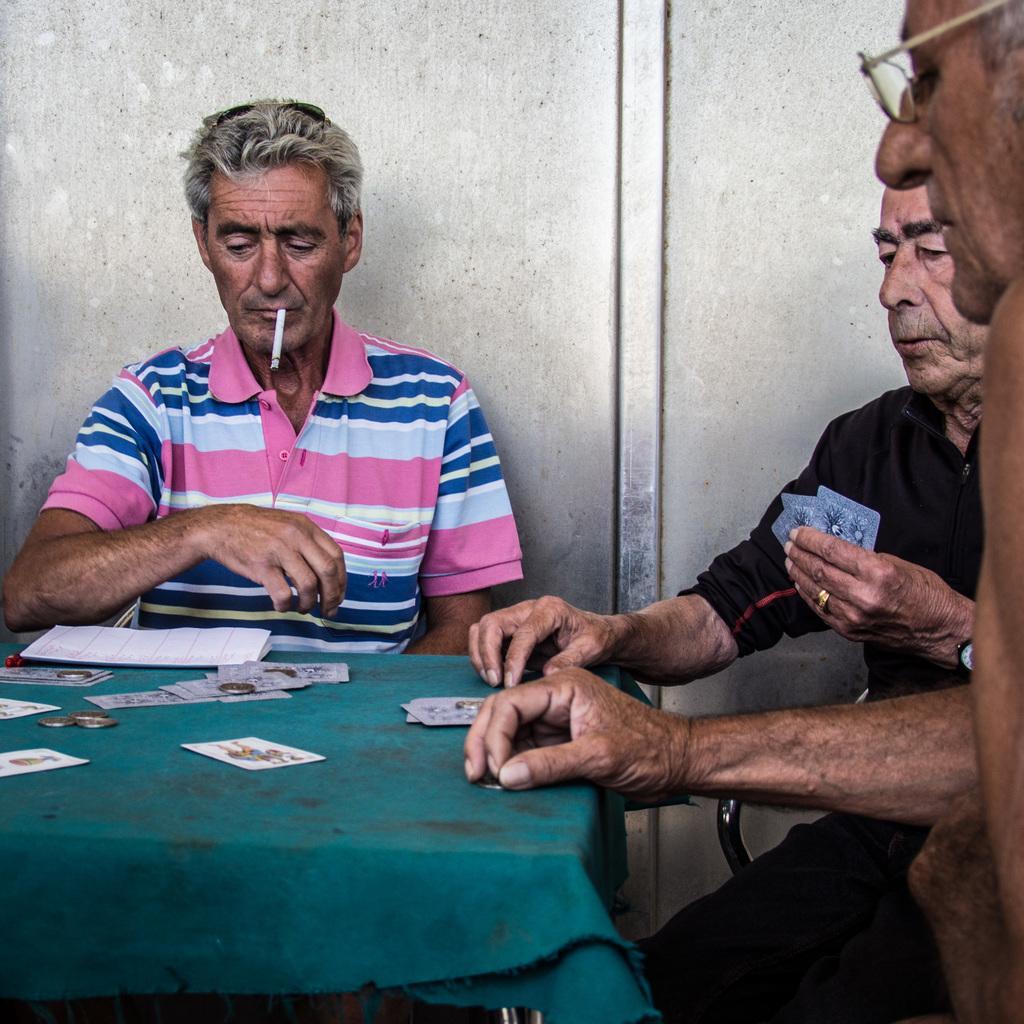Could you give a brief overview of what you see in this image? This is a picture taken in a room, there are three people sitting on chairs. The man in pink t shirt was smoking and the other man in black shirt was holding cards. In front of these people there is a table covered with a cloth on the table there are some coins, paper and cards. 